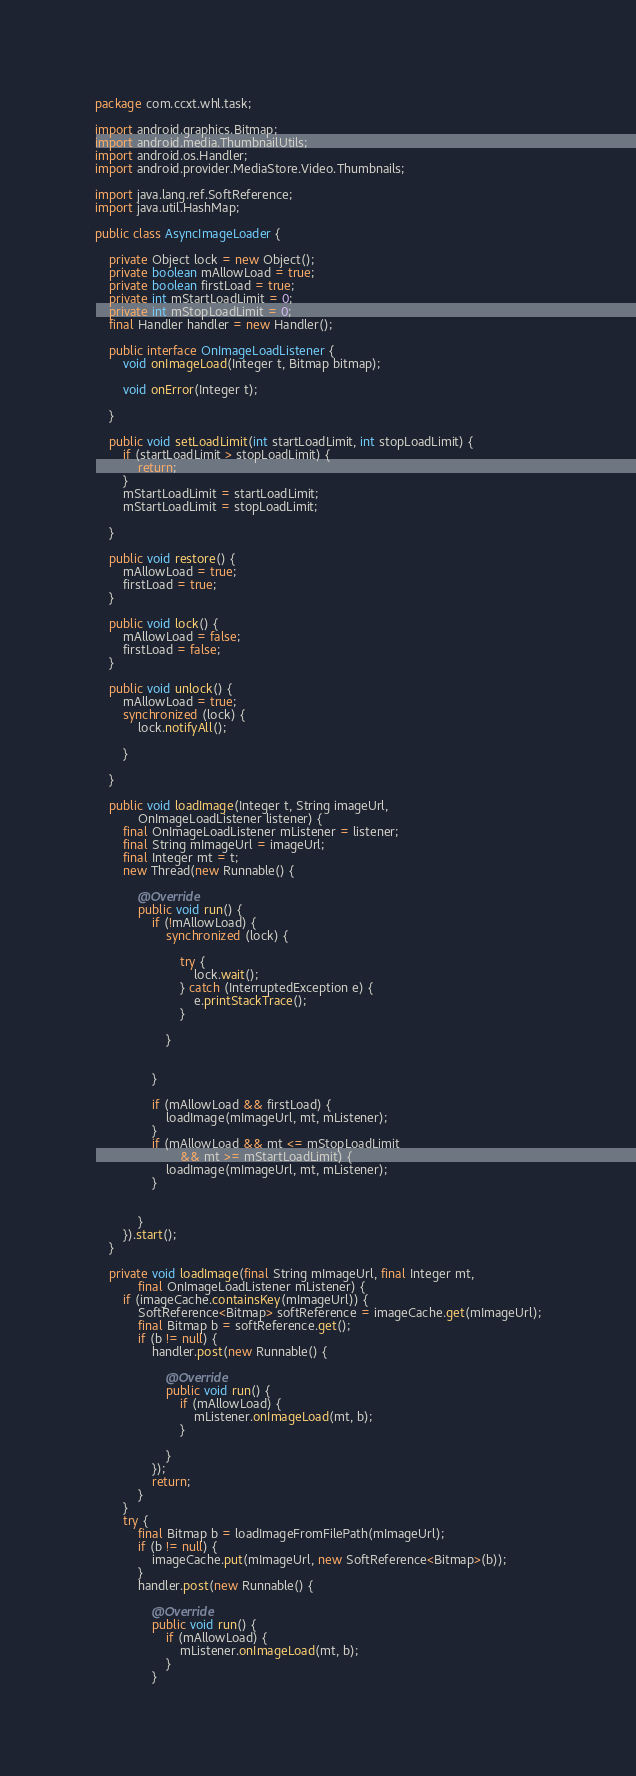Convert code to text. <code><loc_0><loc_0><loc_500><loc_500><_Java_>package com.ccxt.whl.task;

import android.graphics.Bitmap;
import android.media.ThumbnailUtils;
import android.os.Handler;
import android.provider.MediaStore.Video.Thumbnails;

import java.lang.ref.SoftReference;
import java.util.HashMap;

public class AsyncImageLoader {

	private Object lock = new Object();
	private boolean mAllowLoad = true;
	private boolean firstLoad = true;
	private int mStartLoadLimit = 0;
	private int mStopLoadLimit = 0;
	final Handler handler = new Handler();

	public interface OnImageLoadListener {
		void onImageLoad(Integer t, Bitmap bitmap);

		void onError(Integer t);

	}

	public void setLoadLimit(int startLoadLimit, int stopLoadLimit) {
		if (startLoadLimit > stopLoadLimit) {
			return;
		}
		mStartLoadLimit = startLoadLimit;
		mStartLoadLimit = stopLoadLimit;

	}

	public void restore() {
		mAllowLoad = true;
		firstLoad = true;
	}

	public void lock() {
		mAllowLoad = false;
		firstLoad = false;
	}

	public void unlock() {
		mAllowLoad = true;
		synchronized (lock) {
			lock.notifyAll();

		}

	}

	public void loadImage(Integer t, String imageUrl,
			OnImageLoadListener listener) {
		final OnImageLoadListener mListener = listener;
		final String mImageUrl = imageUrl;
		final Integer mt = t;
		new Thread(new Runnable() {

			@Override
			public void run() {
				if (!mAllowLoad) {
					synchronized (lock) {

						try {
							lock.wait();
						} catch (InterruptedException e) {
							e.printStackTrace();
						}

					}

					
				}
				
				if (mAllowLoad && firstLoad) {
					loadImage(mImageUrl, mt, mListener);
				}
				if (mAllowLoad && mt <= mStopLoadLimit
						&& mt >= mStartLoadLimit) {
					loadImage(mImageUrl, mt, mListener);
				}
				
				
			}
		}).start();
	}

	private void loadImage(final String mImageUrl, final Integer mt,
			final OnImageLoadListener mListener) {
		if (imageCache.containsKey(mImageUrl)) {
			SoftReference<Bitmap> softReference = imageCache.get(mImageUrl);
			final Bitmap b = softReference.get();
			if (b != null) {
				handler.post(new Runnable() {

					@Override
					public void run() {
						if (mAllowLoad) {
							mListener.onImageLoad(mt, b);
						}

					}
				});
				return;
			}
		}
		try {
			final Bitmap b = loadImageFromFilePath(mImageUrl);
			if (b != null) {
				imageCache.put(mImageUrl, new SoftReference<Bitmap>(b));
			}
			handler.post(new Runnable() {

				@Override
				public void run() {
					if (mAllowLoad) {
						mListener.onImageLoad(mt, b);
					}
				}</code> 